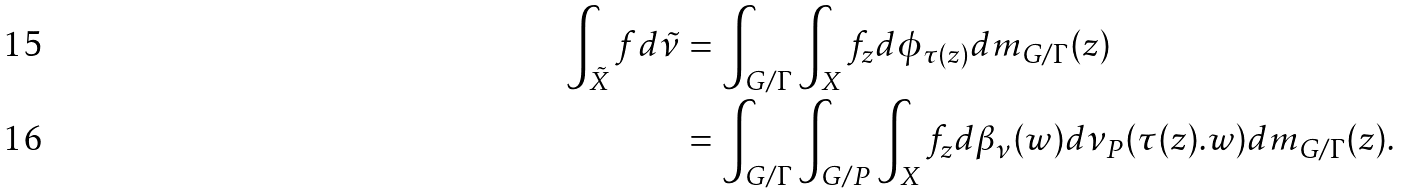Convert formula to latex. <formula><loc_0><loc_0><loc_500><loc_500>\int _ { \tilde { X } } f d \tilde { \nu } & = \int _ { G / \Gamma } \int _ { X } f _ { z } d \phi _ { \tau ( z ) } d m _ { G / \Gamma } ( z ) \\ & = \int _ { G / \Gamma } \int _ { G / P } \int _ { X } f _ { z } d \beta _ { \nu } ( w ) d \nu _ { P } ( \tau ( z ) . w ) d m _ { G / \Gamma } ( z ) .</formula> 